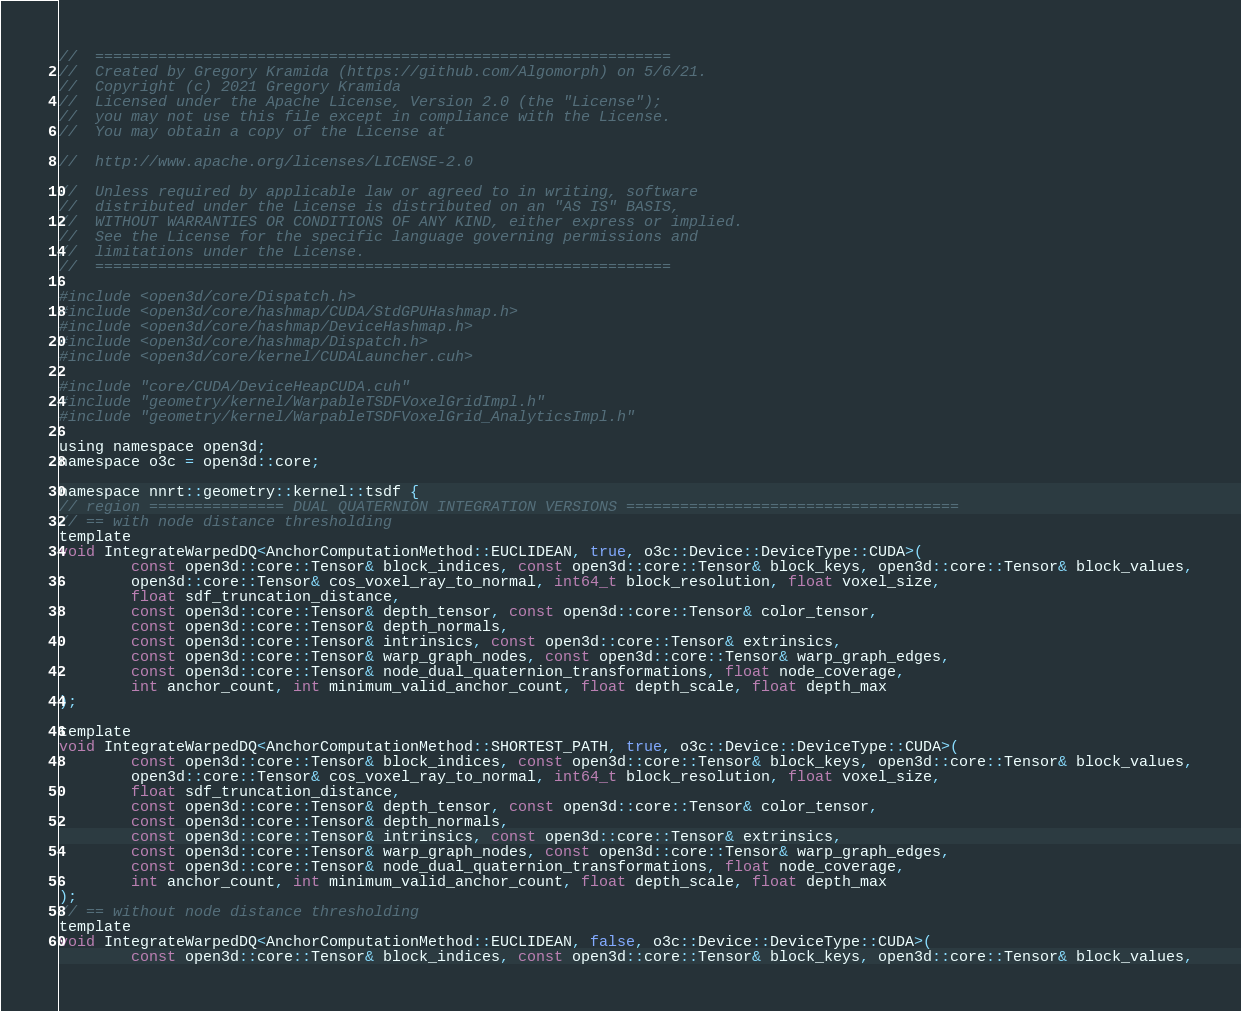Convert code to text. <code><loc_0><loc_0><loc_500><loc_500><_Cuda_>//  ================================================================
//  Created by Gregory Kramida (https://github.com/Algomorph) on 5/6/21.
//  Copyright (c) 2021 Gregory Kramida
//  Licensed under the Apache License, Version 2.0 (the "License");
//  you may not use this file except in compliance with the License.
//  You may obtain a copy of the License at

//  http://www.apache.org/licenses/LICENSE-2.0

//  Unless required by applicable law or agreed to in writing, software
//  distributed under the License is distributed on an "AS IS" BASIS,
//  WITHOUT WARRANTIES OR CONDITIONS OF ANY KIND, either express or implied.
//  See the License for the specific language governing permissions and
//  limitations under the License.
//  ================================================================

#include <open3d/core/Dispatch.h>
#include <open3d/core/hashmap/CUDA/StdGPUHashmap.h>
#include <open3d/core/hashmap/DeviceHashmap.h>
#include <open3d/core/hashmap/Dispatch.h>
#include <open3d/core/kernel/CUDALauncher.cuh>

#include "core/CUDA/DeviceHeapCUDA.cuh"
#include "geometry/kernel/WarpableTSDFVoxelGridImpl.h"
#include "geometry/kernel/WarpableTSDFVoxelGrid_AnalyticsImpl.h"

using namespace open3d;
namespace o3c = open3d::core;

namespace nnrt::geometry::kernel::tsdf {
// region =============== DUAL QUATERNION INTEGRATION VERSIONS =====================================
// == with node distance thresholding
template
void IntegrateWarpedDQ<AnchorComputationMethod::EUCLIDEAN, true, o3c::Device::DeviceType::CUDA>(
		const open3d::core::Tensor& block_indices, const open3d::core::Tensor& block_keys, open3d::core::Tensor& block_values,
		open3d::core::Tensor& cos_voxel_ray_to_normal, int64_t block_resolution, float voxel_size,
		float sdf_truncation_distance,
		const open3d::core::Tensor& depth_tensor, const open3d::core::Tensor& color_tensor,
		const open3d::core::Tensor& depth_normals,
		const open3d::core::Tensor& intrinsics, const open3d::core::Tensor& extrinsics,
		const open3d::core::Tensor& warp_graph_nodes, const open3d::core::Tensor& warp_graph_edges,
		const open3d::core::Tensor& node_dual_quaternion_transformations, float node_coverage,
		int anchor_count, int minimum_valid_anchor_count, float depth_scale, float depth_max
);

template
void IntegrateWarpedDQ<AnchorComputationMethod::SHORTEST_PATH, true, o3c::Device::DeviceType::CUDA>(
		const open3d::core::Tensor& block_indices, const open3d::core::Tensor& block_keys, open3d::core::Tensor& block_values,
		open3d::core::Tensor& cos_voxel_ray_to_normal, int64_t block_resolution, float voxel_size,
		float sdf_truncation_distance,
		const open3d::core::Tensor& depth_tensor, const open3d::core::Tensor& color_tensor,
		const open3d::core::Tensor& depth_normals,
		const open3d::core::Tensor& intrinsics, const open3d::core::Tensor& extrinsics,
		const open3d::core::Tensor& warp_graph_nodes, const open3d::core::Tensor& warp_graph_edges,
		const open3d::core::Tensor& node_dual_quaternion_transformations, float node_coverage,
		int anchor_count, int minimum_valid_anchor_count, float depth_scale, float depth_max
);
// == without node distance thresholding
template
void IntegrateWarpedDQ<AnchorComputationMethod::EUCLIDEAN, false, o3c::Device::DeviceType::CUDA>(
		const open3d::core::Tensor& block_indices, const open3d::core::Tensor& block_keys, open3d::core::Tensor& block_values,</code> 